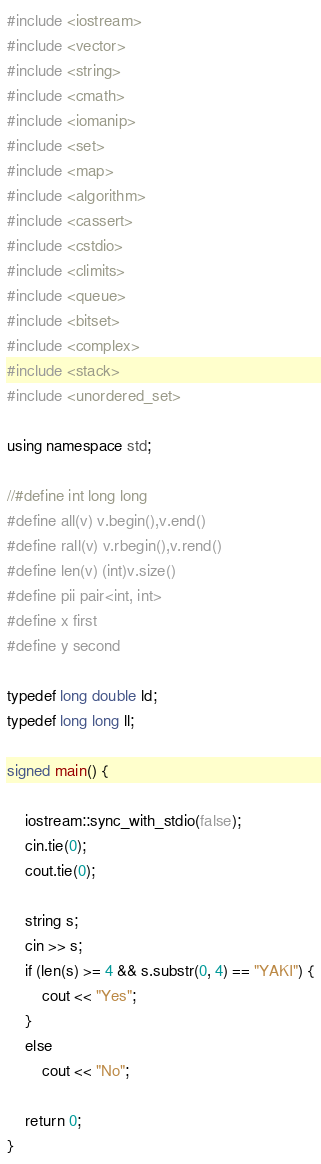<code> <loc_0><loc_0><loc_500><loc_500><_C++_>#include <iostream>
#include <vector>
#include <string>
#include <cmath>
#include <iomanip>
#include <set>
#include <map>
#include <algorithm>
#include <cassert>
#include <cstdio>
#include <climits>
#include <queue>
#include <bitset>
#include <complex>
#include <stack>
#include <unordered_set>

using namespace std;

//#define int long long
#define all(v) v.begin(),v.end()
#define rall(v) v.rbegin(),v.rend()
#define len(v) (int)v.size()
#define pii pair<int, int>
#define x first
#define y second

typedef long double ld;
typedef long long ll;

signed main() {
    
    iostream::sync_with_stdio(false);
    cin.tie(0);
    cout.tie(0);
 
    string s;
    cin >> s;
    if (len(s) >= 4 && s.substr(0, 4) == "YAKI") {
        cout << "Yes";
    }
    else
        cout << "No";
    
    return 0;
}</code> 